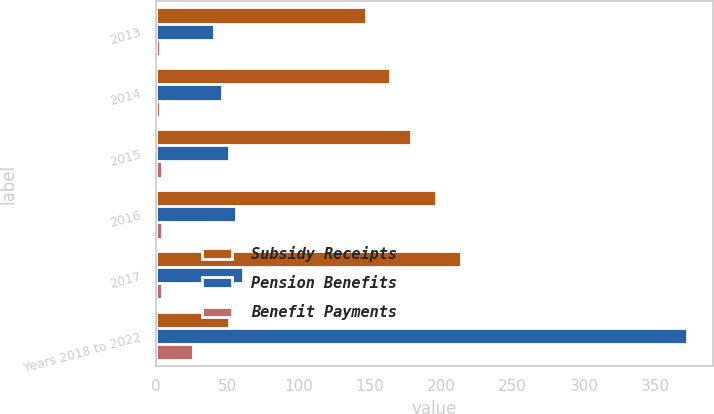<chart> <loc_0><loc_0><loc_500><loc_500><stacked_bar_chart><ecel><fcel>2013<fcel>2014<fcel>2015<fcel>2016<fcel>2017<fcel>Years 2018 to 2022<nl><fcel>Subsidy Receipts<fcel>147<fcel>164<fcel>179<fcel>196<fcel>214<fcel>51<nl><fcel>Pension Benefits<fcel>41<fcel>46<fcel>51<fcel>56<fcel>61<fcel>372<nl><fcel>Benefit Payments<fcel>3<fcel>3<fcel>4<fcel>4<fcel>4<fcel>26<nl></chart> 